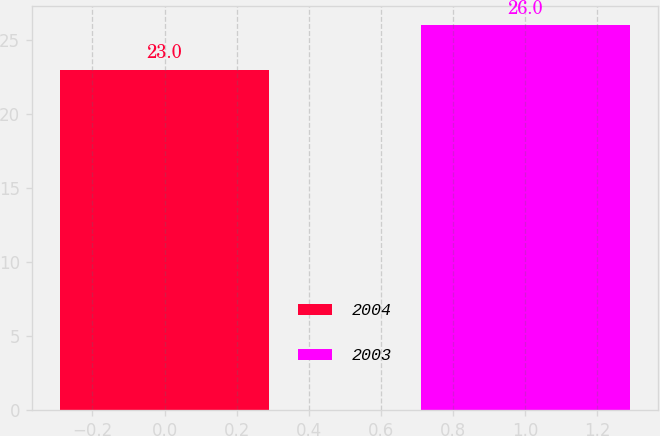Convert chart to OTSL. <chart><loc_0><loc_0><loc_500><loc_500><bar_chart><fcel>2004<fcel>2003<nl><fcel>23<fcel>26<nl></chart> 